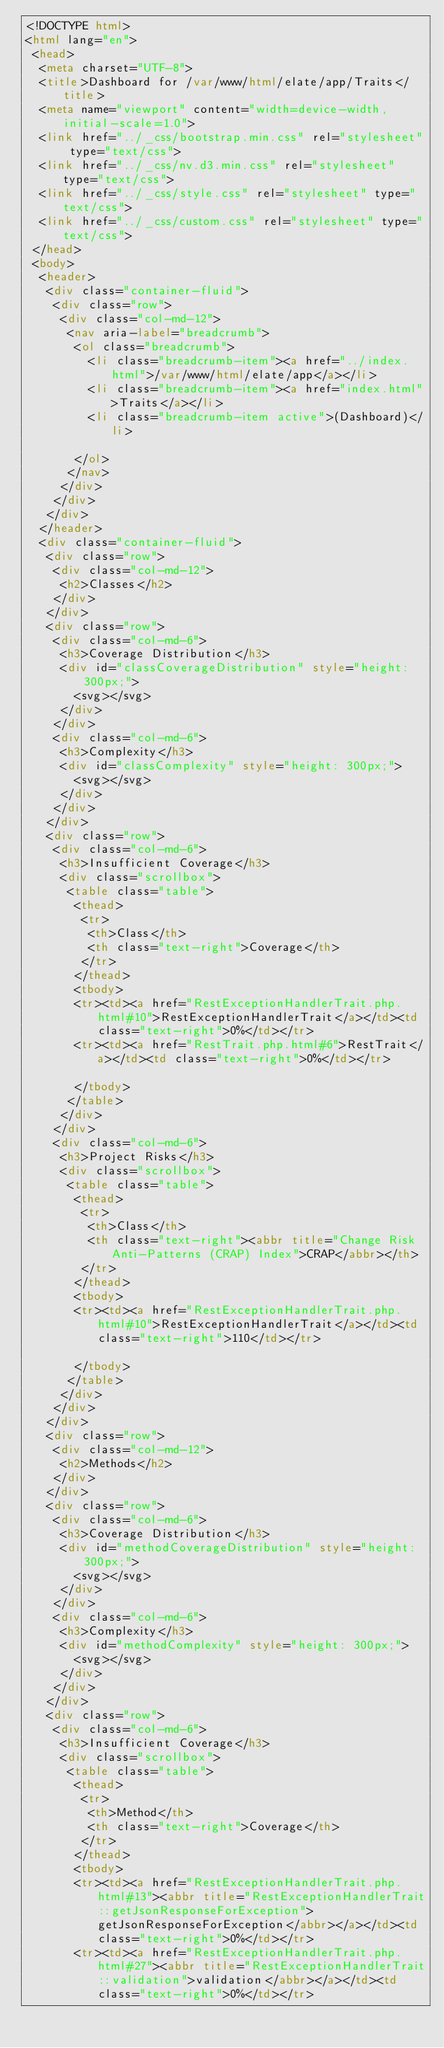<code> <loc_0><loc_0><loc_500><loc_500><_HTML_><!DOCTYPE html>
<html lang="en">
 <head>
  <meta charset="UTF-8">
  <title>Dashboard for /var/www/html/elate/app/Traits</title>
  <meta name="viewport" content="width=device-width, initial-scale=1.0">
  <link href="../_css/bootstrap.min.css" rel="stylesheet" type="text/css">
  <link href="../_css/nv.d3.min.css" rel="stylesheet" type="text/css">
  <link href="../_css/style.css" rel="stylesheet" type="text/css">
  <link href="../_css/custom.css" rel="stylesheet" type="text/css">
 </head>
 <body>
  <header>
   <div class="container-fluid">
    <div class="row">
     <div class="col-md-12">
      <nav aria-label="breadcrumb">
       <ol class="breadcrumb">
         <li class="breadcrumb-item"><a href="../index.html">/var/www/html/elate/app</a></li>
         <li class="breadcrumb-item"><a href="index.html">Traits</a></li>
         <li class="breadcrumb-item active">(Dashboard)</li>

       </ol>
      </nav>
     </div>
    </div>
   </div>
  </header>
  <div class="container-fluid">
   <div class="row">
    <div class="col-md-12">
     <h2>Classes</h2>
    </div>
   </div>
   <div class="row">
    <div class="col-md-6">
     <h3>Coverage Distribution</h3>
     <div id="classCoverageDistribution" style="height: 300px;">
       <svg></svg>
     </div>
    </div>
    <div class="col-md-6">
     <h3>Complexity</h3>
     <div id="classComplexity" style="height: 300px;">
       <svg></svg>
     </div>
    </div>
   </div>
   <div class="row">
    <div class="col-md-6">
     <h3>Insufficient Coverage</h3>
     <div class="scrollbox">
      <table class="table">
       <thead>
        <tr>
         <th>Class</th>
         <th class="text-right">Coverage</th>
        </tr>
       </thead>
       <tbody>
       <tr><td><a href="RestExceptionHandlerTrait.php.html#10">RestExceptionHandlerTrait</a></td><td class="text-right">0%</td></tr>
       <tr><td><a href="RestTrait.php.html#6">RestTrait</a></td><td class="text-right">0%</td></tr>

       </tbody>
      </table>
     </div>
    </div>
    <div class="col-md-6">
     <h3>Project Risks</h3>
     <div class="scrollbox">
      <table class="table">
       <thead>
        <tr>
         <th>Class</th>
         <th class="text-right"><abbr title="Change Risk Anti-Patterns (CRAP) Index">CRAP</abbr></th>
        </tr>
       </thead>
       <tbody>
       <tr><td><a href="RestExceptionHandlerTrait.php.html#10">RestExceptionHandlerTrait</a></td><td class="text-right">110</td></tr>

       </tbody>
      </table>
     </div>
    </div>
   </div>
   <div class="row">
    <div class="col-md-12">
     <h2>Methods</h2>
    </div>
   </div>
   <div class="row">
    <div class="col-md-6">
     <h3>Coverage Distribution</h3>
     <div id="methodCoverageDistribution" style="height: 300px;">
       <svg></svg>
     </div>
    </div>
    <div class="col-md-6">
     <h3>Complexity</h3>
     <div id="methodComplexity" style="height: 300px;">
       <svg></svg>
     </div>
    </div>
   </div>
   <div class="row">
    <div class="col-md-6">
     <h3>Insufficient Coverage</h3>
     <div class="scrollbox">
      <table class="table">
       <thead>
        <tr>
         <th>Method</th>
         <th class="text-right">Coverage</th>
        </tr>
       </thead>
       <tbody>
       <tr><td><a href="RestExceptionHandlerTrait.php.html#13"><abbr title="RestExceptionHandlerTrait::getJsonResponseForException">getJsonResponseForException</abbr></a></td><td class="text-right">0%</td></tr>
       <tr><td><a href="RestExceptionHandlerTrait.php.html#27"><abbr title="RestExceptionHandlerTrait::validation">validation</abbr></a></td><td class="text-right">0%</td></tr></code> 